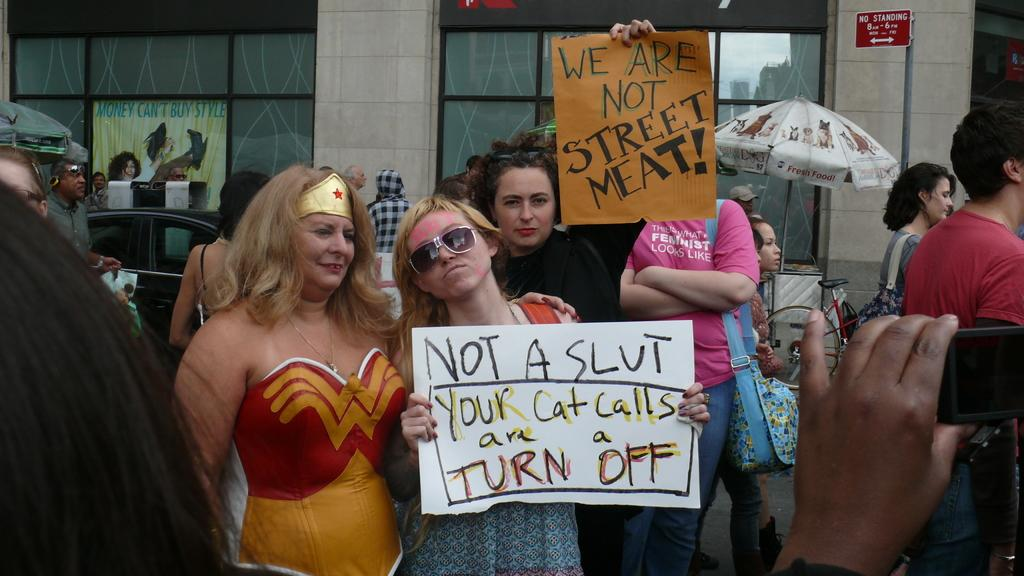How many people are present in the image? There are many people in the image. What are the people holding in the image? The people are holding papers. What can be seen in the background of the image? There is a building in the background of the image. Can you describe the small umbrella-like object in the middle of the image? There is a small umbrella-like object in the middle of the image. Are there any pigs present in the image? There are no pigs present in the image. What type of payment is being exchanged between the people in the image? There is no indication of any payment being exchanged in the image. 